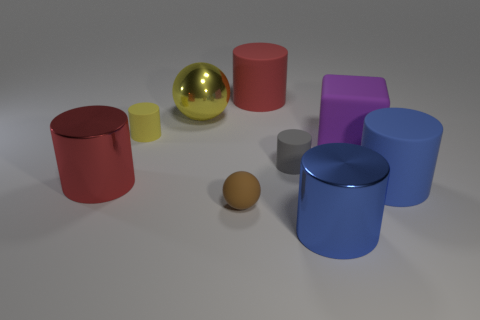Subtract all blue cylinders. How many were subtracted if there are1blue cylinders left? 1 Subtract all large shiny cylinders. How many cylinders are left? 4 Subtract all blue cylinders. How many cylinders are left? 4 Subtract all brown cylinders. Subtract all red cubes. How many cylinders are left? 6 Subtract all blocks. How many objects are left? 8 Subtract 2 red cylinders. How many objects are left? 7 Subtract all yellow matte spheres. Subtract all matte cylinders. How many objects are left? 5 Add 7 brown matte spheres. How many brown matte spheres are left? 8 Add 1 small cyan spheres. How many small cyan spheres exist? 1 